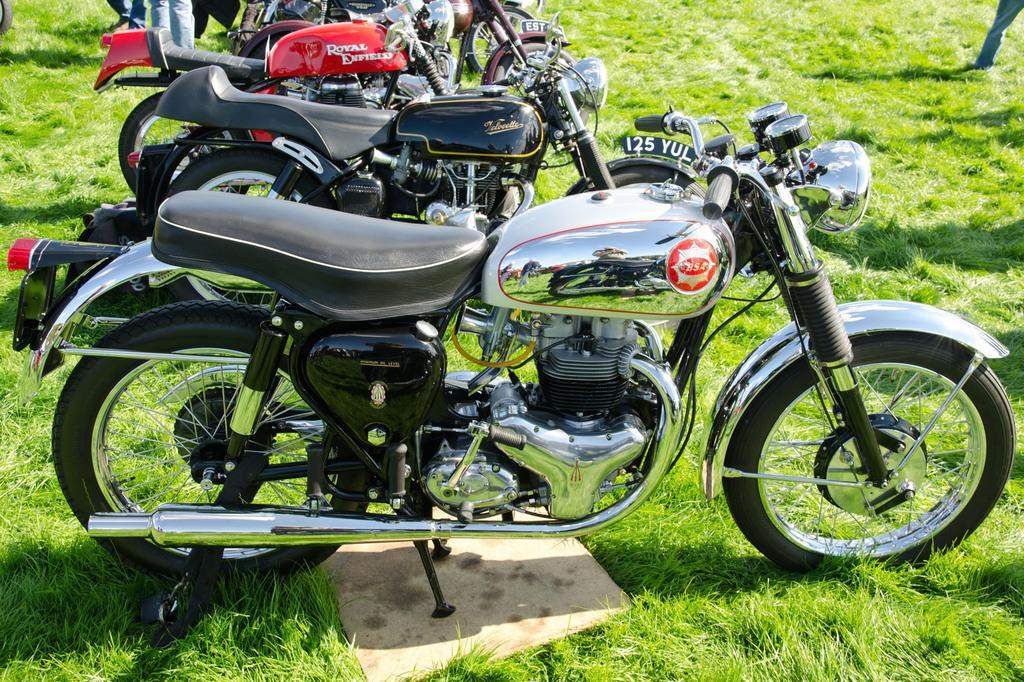What type of vehicles are present in the image? There are bikes in the image. Where are the bikes located? The bikes are on the glass. What type of trail can be seen behind the bikes in the image? There is no trail visible in the image; the bikes are on the glass. What emotion is being expressed by the bikes in the image? Bikes do not express emotions, so this question cannot be answered. 